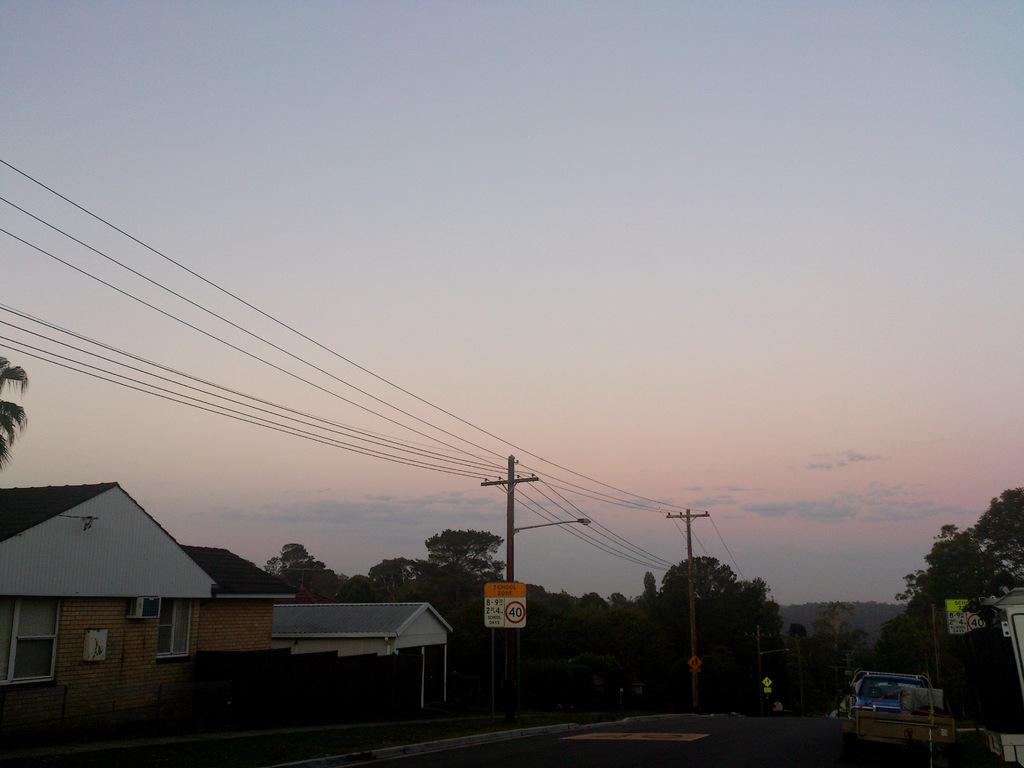What type of structure is present in the image? There is a house in the image. What features can be observed on the house? The house has windows. What other objects or elements are visible in the image? There are trees, poles with cables, a road, and the sky is visible in the image. What color is the kitten playing with a shoe in the image? There is no kitten or shoe present in the image. What type of silver object can be seen in the image? There is no silver object present in the image. 